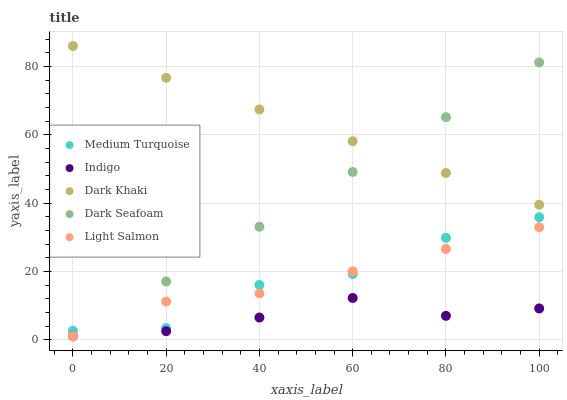Does Indigo have the minimum area under the curve?
Answer yes or no. Yes. Does Dark Khaki have the maximum area under the curve?
Answer yes or no. Yes. Does Dark Seafoam have the minimum area under the curve?
Answer yes or no. No. Does Dark Seafoam have the maximum area under the curve?
Answer yes or no. No. Is Dark Seafoam the smoothest?
Answer yes or no. Yes. Is Medium Turquoise the roughest?
Answer yes or no. Yes. Is Indigo the smoothest?
Answer yes or no. No. Is Indigo the roughest?
Answer yes or no. No. Does Dark Seafoam have the lowest value?
Answer yes or no. Yes. Does Medium Turquoise have the lowest value?
Answer yes or no. No. Does Dark Khaki have the highest value?
Answer yes or no. Yes. Does Dark Seafoam have the highest value?
Answer yes or no. No. Is Light Salmon less than Dark Khaki?
Answer yes or no. Yes. Is Dark Khaki greater than Light Salmon?
Answer yes or no. Yes. Does Light Salmon intersect Indigo?
Answer yes or no. Yes. Is Light Salmon less than Indigo?
Answer yes or no. No. Is Light Salmon greater than Indigo?
Answer yes or no. No. Does Light Salmon intersect Dark Khaki?
Answer yes or no. No. 